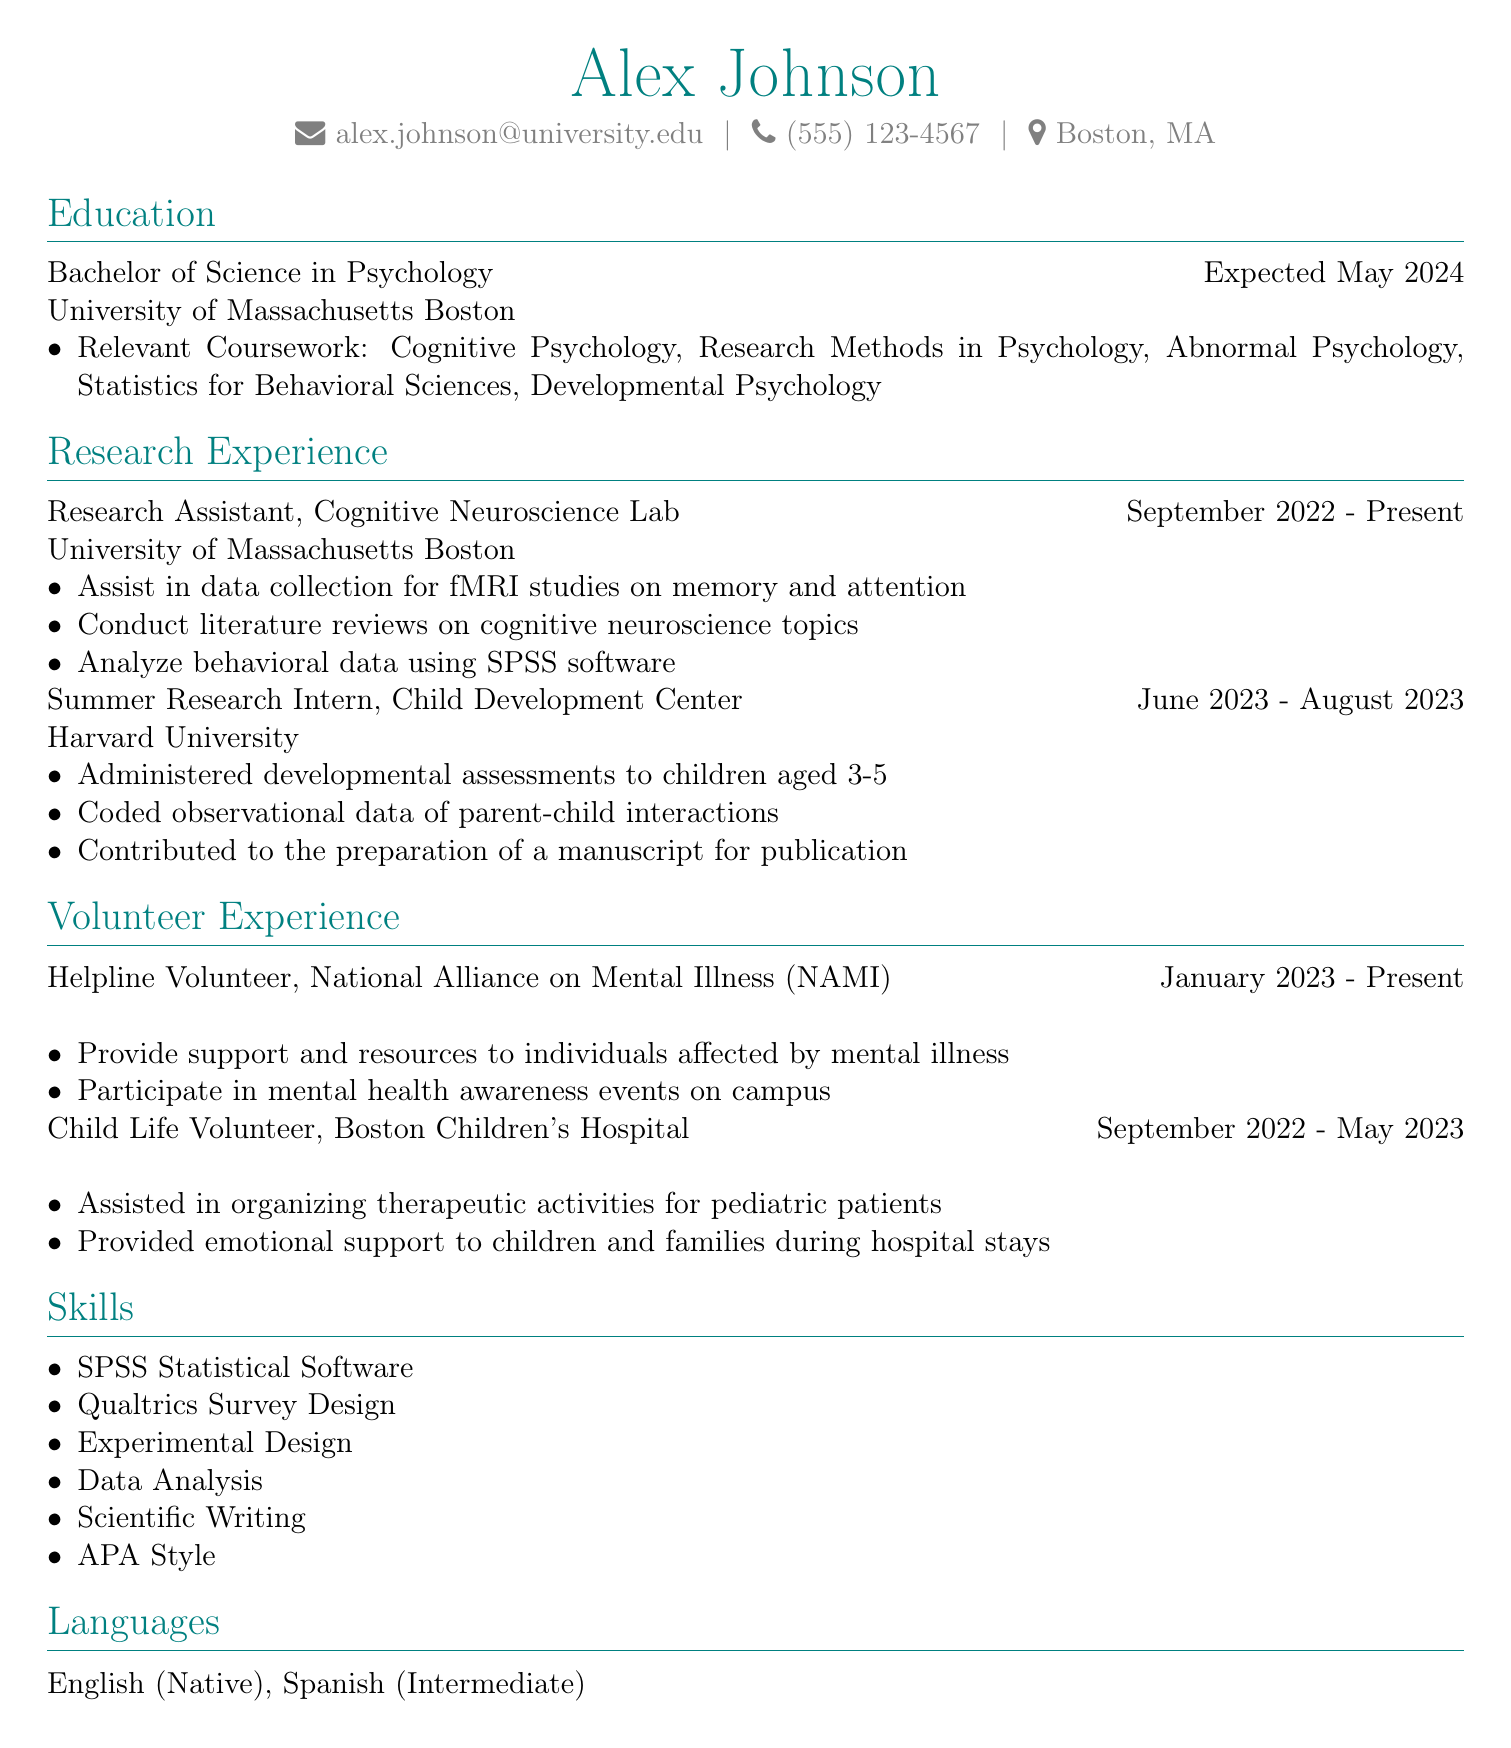What is the name of the student? The student's name is provided in the personal information section of the CV.
Answer: Alex Johnson What is the expected graduation date? The expected graduation date is found in the education section.
Answer: May 2024 Which lab did Alex work as a Research Assistant? The CV lists the cognitive neuroscience lab in the research experience section.
Answer: Cognitive Neuroscience Lab What organization does Alex volunteer for as a Helpline Volunteer? The name of the organization is mentioned in the volunteer experience section.
Answer: National Alliance on Mental Illness (NAMI) What position did Alex hold at Harvard University? The position is specified under the research experience section of the CV.
Answer: Summer Research Intern Which statistical software does Alex have skills in? The skills section lists specific skills, including software tools.
Answer: SPSS Statistical Software How long did Alex volunteer at Boston Children's Hospital? This information can be calculated from the time span mentioned in the volunteer experience section.
Answer: September 2022 - May 2023 How many relevant coursework subjects are listed? The number of subjects is found in the education section under relevant coursework.
Answer: Five What is Alex's intermediate language skill? The languages section indicates Alex's level in various languages.
Answer: Spanish 